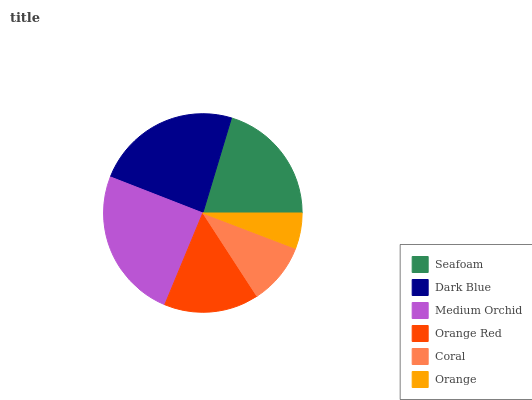Is Orange the minimum?
Answer yes or no. Yes. Is Medium Orchid the maximum?
Answer yes or no. Yes. Is Dark Blue the minimum?
Answer yes or no. No. Is Dark Blue the maximum?
Answer yes or no. No. Is Dark Blue greater than Seafoam?
Answer yes or no. Yes. Is Seafoam less than Dark Blue?
Answer yes or no. Yes. Is Seafoam greater than Dark Blue?
Answer yes or no. No. Is Dark Blue less than Seafoam?
Answer yes or no. No. Is Seafoam the high median?
Answer yes or no. Yes. Is Orange Red the low median?
Answer yes or no. Yes. Is Medium Orchid the high median?
Answer yes or no. No. Is Medium Orchid the low median?
Answer yes or no. No. 